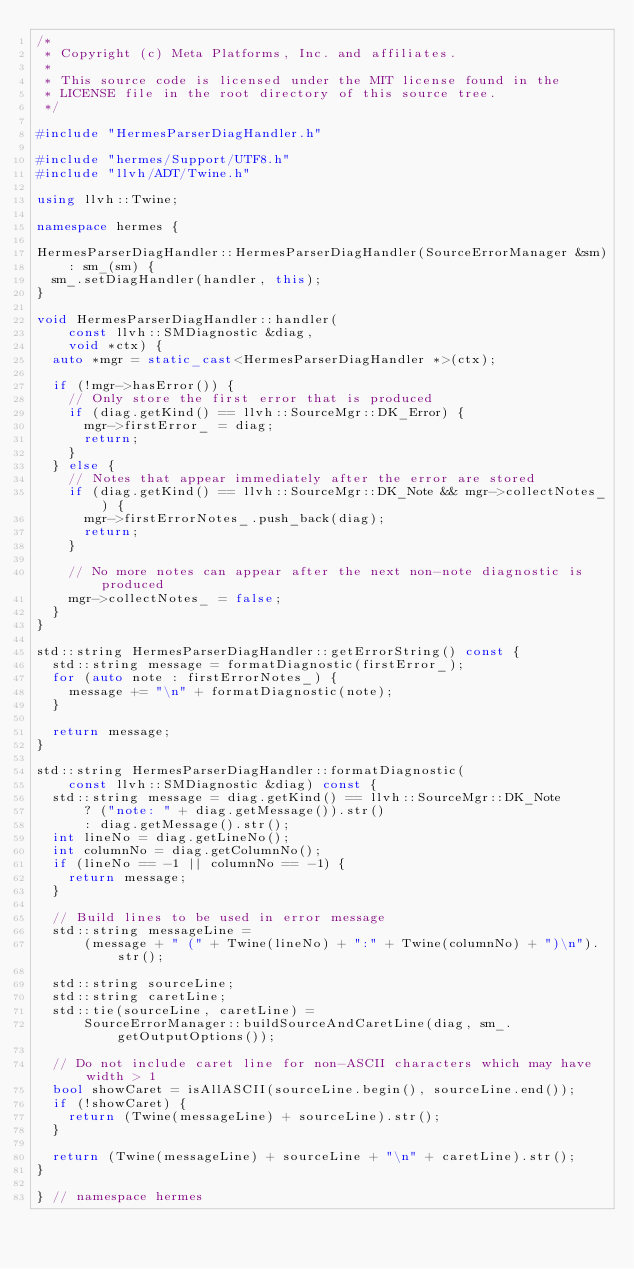Convert code to text. <code><loc_0><loc_0><loc_500><loc_500><_C++_>/*
 * Copyright (c) Meta Platforms, Inc. and affiliates.
 *
 * This source code is licensed under the MIT license found in the
 * LICENSE file in the root directory of this source tree.
 */

#include "HermesParserDiagHandler.h"

#include "hermes/Support/UTF8.h"
#include "llvh/ADT/Twine.h"

using llvh::Twine;

namespace hermes {

HermesParserDiagHandler::HermesParserDiagHandler(SourceErrorManager &sm)
    : sm_(sm) {
  sm_.setDiagHandler(handler, this);
}

void HermesParserDiagHandler::handler(
    const llvh::SMDiagnostic &diag,
    void *ctx) {
  auto *mgr = static_cast<HermesParserDiagHandler *>(ctx);

  if (!mgr->hasError()) {
    // Only store the first error that is produced
    if (diag.getKind() == llvh::SourceMgr::DK_Error) {
      mgr->firstError_ = diag;
      return;
    }
  } else {
    // Notes that appear immediately after the error are stored
    if (diag.getKind() == llvh::SourceMgr::DK_Note && mgr->collectNotes_) {
      mgr->firstErrorNotes_.push_back(diag);
      return;
    }

    // No more notes can appear after the next non-note diagnostic is produced
    mgr->collectNotes_ = false;
  }
}

std::string HermesParserDiagHandler::getErrorString() const {
  std::string message = formatDiagnostic(firstError_);
  for (auto note : firstErrorNotes_) {
    message += "\n" + formatDiagnostic(note);
  }

  return message;
}

std::string HermesParserDiagHandler::formatDiagnostic(
    const llvh::SMDiagnostic &diag) const {
  std::string message = diag.getKind() == llvh::SourceMgr::DK_Note
      ? ("note: " + diag.getMessage()).str()
      : diag.getMessage().str();
  int lineNo = diag.getLineNo();
  int columnNo = diag.getColumnNo();
  if (lineNo == -1 || columnNo == -1) {
    return message;
  }

  // Build lines to be used in error message
  std::string messageLine =
      (message + " (" + Twine(lineNo) + ":" + Twine(columnNo) + ")\n").str();

  std::string sourceLine;
  std::string caretLine;
  std::tie(sourceLine, caretLine) =
      SourceErrorManager::buildSourceAndCaretLine(diag, sm_.getOutputOptions());

  // Do not include caret line for non-ASCII characters which may have width > 1
  bool showCaret = isAllASCII(sourceLine.begin(), sourceLine.end());
  if (!showCaret) {
    return (Twine(messageLine) + sourceLine).str();
  }

  return (Twine(messageLine) + sourceLine + "\n" + caretLine).str();
}

} // namespace hermes
</code> 